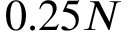Convert formula to latex. <formula><loc_0><loc_0><loc_500><loc_500>0 . 2 5 N</formula> 